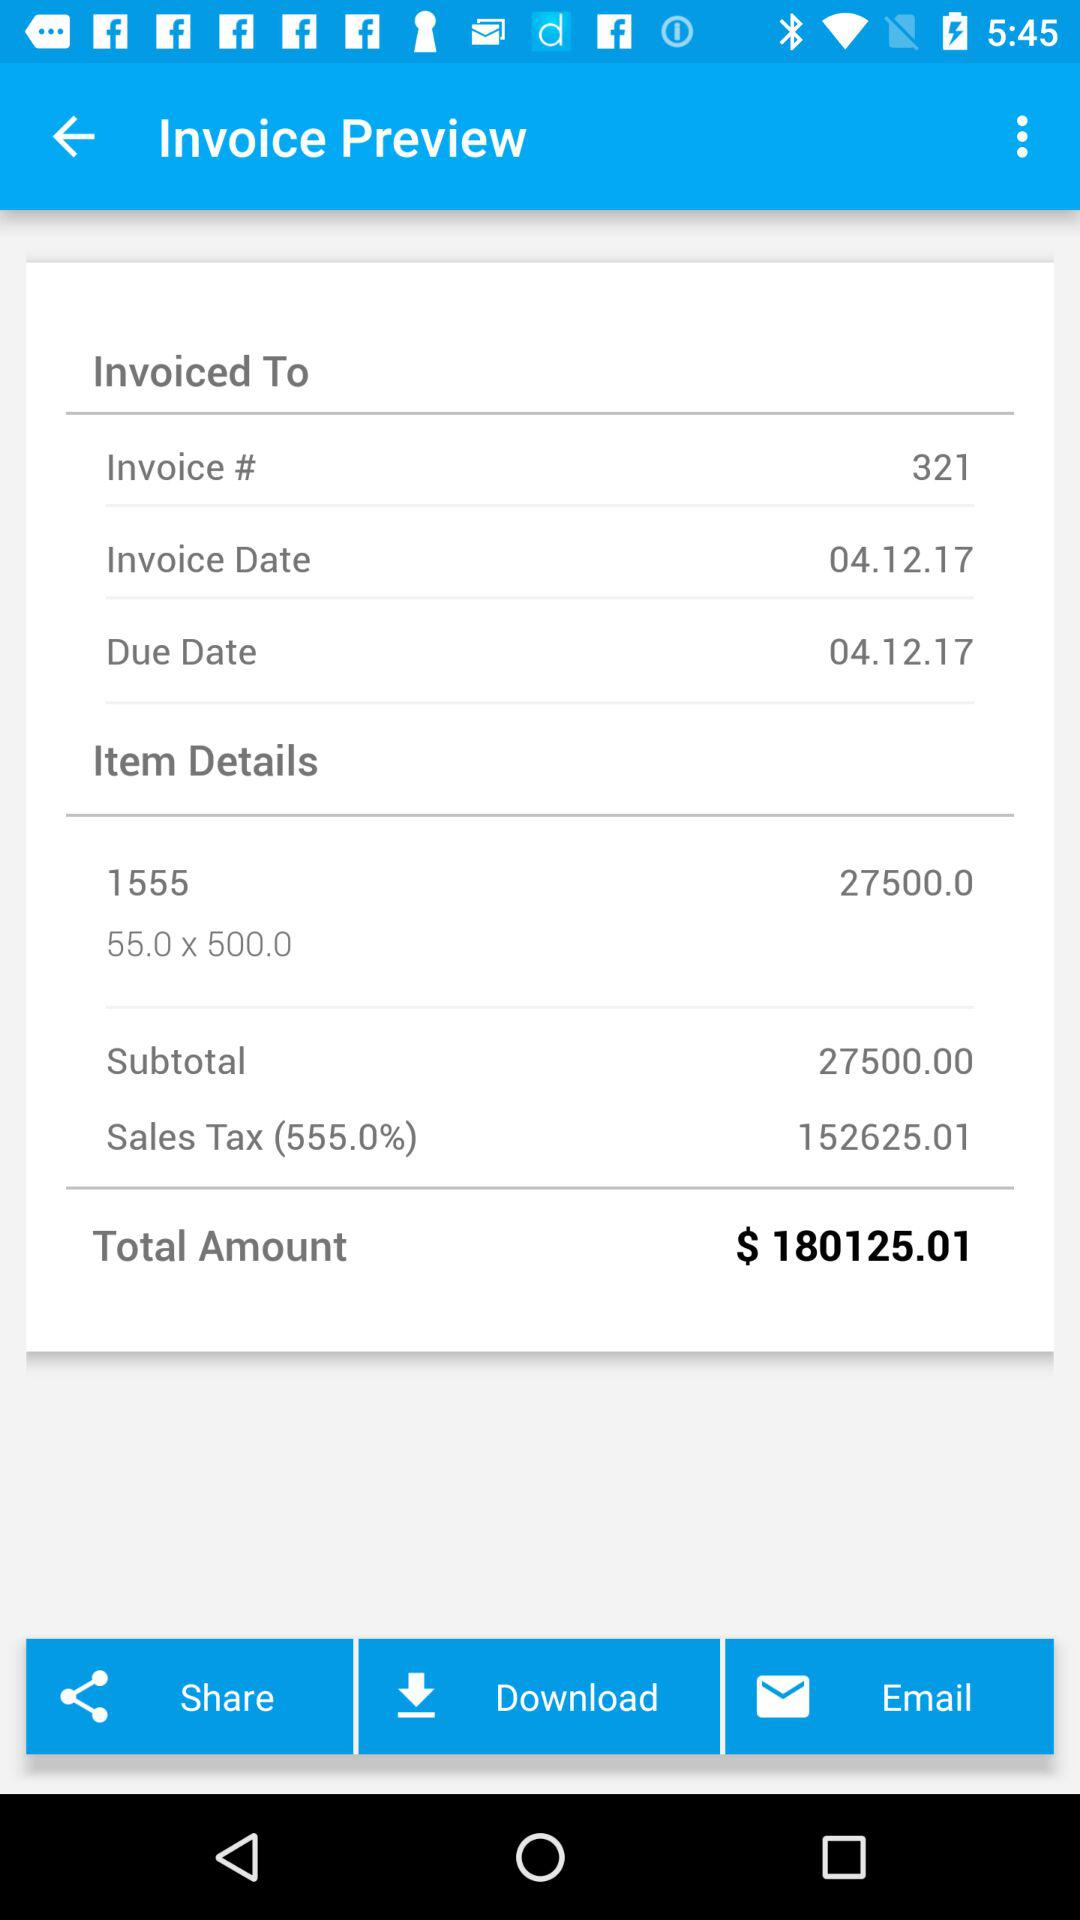What is the total amount of the sales tax? The total amount of the sales tax is 152625.01. 